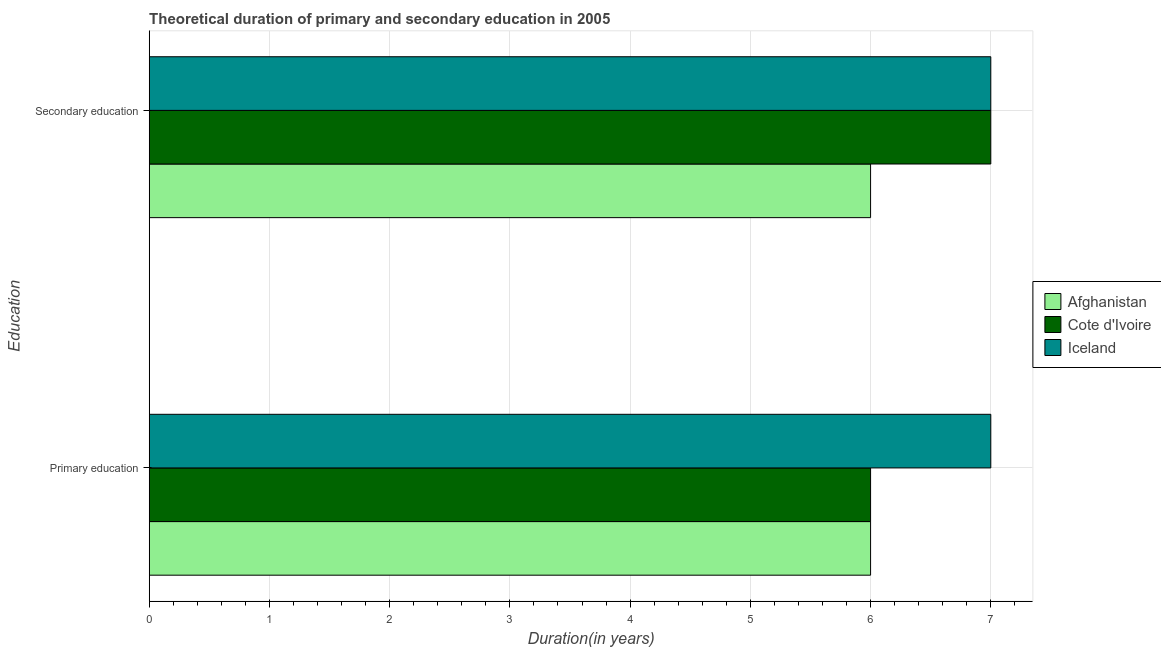How many groups of bars are there?
Provide a succinct answer. 2. Are the number of bars per tick equal to the number of legend labels?
Provide a succinct answer. Yes. Are the number of bars on each tick of the Y-axis equal?
Offer a very short reply. Yes. How many bars are there on the 1st tick from the top?
Keep it short and to the point. 3. How many bars are there on the 2nd tick from the bottom?
Provide a short and direct response. 3. Across all countries, what is the maximum duration of secondary education?
Make the answer very short. 7. Across all countries, what is the minimum duration of primary education?
Provide a short and direct response. 6. In which country was the duration of secondary education maximum?
Make the answer very short. Cote d'Ivoire. In which country was the duration of secondary education minimum?
Your answer should be compact. Afghanistan. What is the total duration of secondary education in the graph?
Ensure brevity in your answer.  20. What is the difference between the duration of secondary education in Cote d'Ivoire and that in Afghanistan?
Keep it short and to the point. 1. What is the average duration of primary education per country?
Provide a short and direct response. 6.33. What is the difference between the duration of primary education and duration of secondary education in Afghanistan?
Provide a short and direct response. 0. What is the ratio of the duration of secondary education in Afghanistan to that in Cote d'Ivoire?
Give a very brief answer. 0.86. In how many countries, is the duration of secondary education greater than the average duration of secondary education taken over all countries?
Give a very brief answer. 2. What does the 2nd bar from the top in Secondary education represents?
Your response must be concise. Cote d'Ivoire. What does the 2nd bar from the bottom in Primary education represents?
Your response must be concise. Cote d'Ivoire. How many bars are there?
Provide a succinct answer. 6. Does the graph contain grids?
Keep it short and to the point. Yes. How many legend labels are there?
Offer a terse response. 3. How are the legend labels stacked?
Your answer should be very brief. Vertical. What is the title of the graph?
Keep it short and to the point. Theoretical duration of primary and secondary education in 2005. What is the label or title of the X-axis?
Provide a succinct answer. Duration(in years). What is the label or title of the Y-axis?
Offer a very short reply. Education. What is the Duration(in years) in Afghanistan in Primary education?
Keep it short and to the point. 6. What is the Duration(in years) of Iceland in Primary education?
Your answer should be compact. 7. What is the Duration(in years) in Iceland in Secondary education?
Your answer should be compact. 7. Across all Education, what is the minimum Duration(in years) of Cote d'Ivoire?
Offer a terse response. 6. Across all Education, what is the minimum Duration(in years) of Iceland?
Make the answer very short. 7. What is the total Duration(in years) of Afghanistan in the graph?
Offer a very short reply. 12. What is the total Duration(in years) in Iceland in the graph?
Provide a short and direct response. 14. What is the average Duration(in years) of Afghanistan per Education?
Provide a short and direct response. 6. What is the average Duration(in years) in Iceland per Education?
Ensure brevity in your answer.  7. What is the difference between the Duration(in years) of Afghanistan and Duration(in years) of Cote d'Ivoire in Primary education?
Your response must be concise. 0. What is the difference between the Duration(in years) of Afghanistan and Duration(in years) of Iceland in Primary education?
Provide a succinct answer. -1. What is the difference between the Duration(in years) in Cote d'Ivoire and Duration(in years) in Iceland in Primary education?
Your answer should be compact. -1. What is the ratio of the Duration(in years) of Afghanistan in Primary education to that in Secondary education?
Offer a terse response. 1. What is the difference between the highest and the second highest Duration(in years) of Afghanistan?
Give a very brief answer. 0. What is the difference between the highest and the second highest Duration(in years) in Iceland?
Make the answer very short. 0. What is the difference between the highest and the lowest Duration(in years) in Afghanistan?
Make the answer very short. 0. What is the difference between the highest and the lowest Duration(in years) in Iceland?
Keep it short and to the point. 0. 